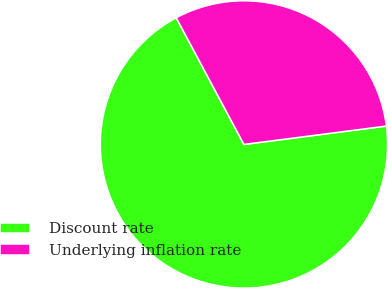<chart> <loc_0><loc_0><loc_500><loc_500><pie_chart><fcel>Discount rate<fcel>Underlying inflation rate<nl><fcel>69.23%<fcel>30.77%<nl></chart> 